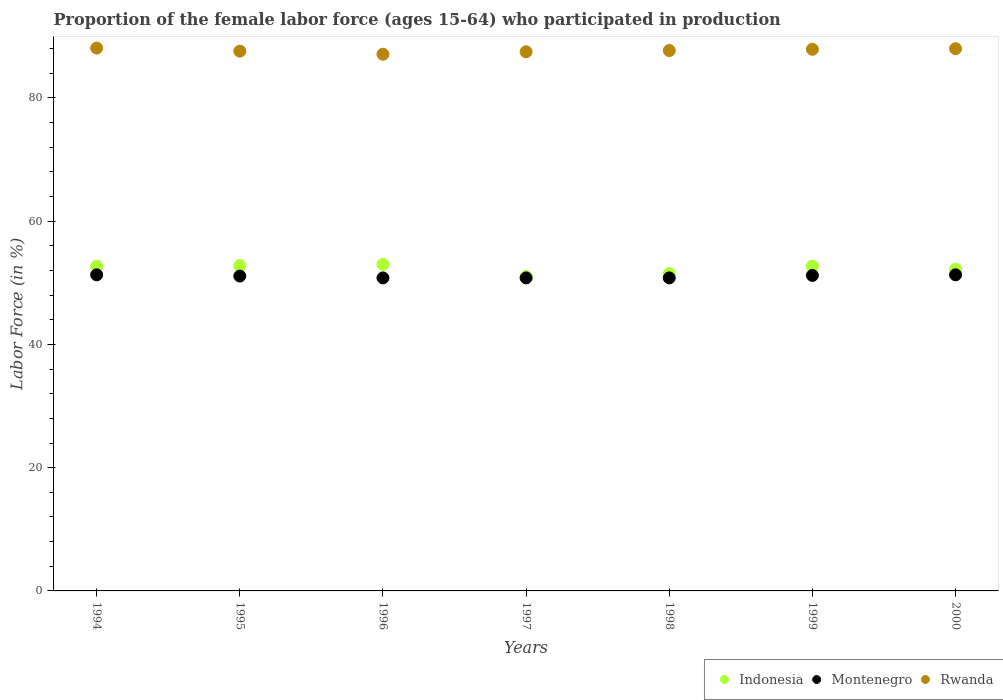What is the proportion of the female labor force who participated in production in Indonesia in 1996?
Give a very brief answer. 53. Across all years, what is the maximum proportion of the female labor force who participated in production in Montenegro?
Ensure brevity in your answer.  51.3. Across all years, what is the minimum proportion of the female labor force who participated in production in Montenegro?
Keep it short and to the point. 50.8. In which year was the proportion of the female labor force who participated in production in Rwanda maximum?
Your response must be concise. 1994. What is the total proportion of the female labor force who participated in production in Montenegro in the graph?
Keep it short and to the point. 357.3. What is the difference between the proportion of the female labor force who participated in production in Indonesia in 1996 and that in 1997?
Give a very brief answer. 2. What is the difference between the proportion of the female labor force who participated in production in Rwanda in 1994 and the proportion of the female labor force who participated in production in Indonesia in 1995?
Your answer should be very brief. 35.3. What is the average proportion of the female labor force who participated in production in Indonesia per year?
Offer a very short reply. 52.27. In the year 1997, what is the difference between the proportion of the female labor force who participated in production in Indonesia and proportion of the female labor force who participated in production in Rwanda?
Give a very brief answer. -36.5. In how many years, is the proportion of the female labor force who participated in production in Rwanda greater than 60 %?
Your response must be concise. 7. What is the ratio of the proportion of the female labor force who participated in production in Montenegro in 1999 to that in 2000?
Give a very brief answer. 1. Is the proportion of the female labor force who participated in production in Montenegro in 1999 less than that in 2000?
Give a very brief answer. Yes. What is the difference between the highest and the second highest proportion of the female labor force who participated in production in Indonesia?
Provide a succinct answer. 0.2. Does the proportion of the female labor force who participated in production in Indonesia monotonically increase over the years?
Offer a terse response. No. Is the proportion of the female labor force who participated in production in Montenegro strictly greater than the proportion of the female labor force who participated in production in Indonesia over the years?
Give a very brief answer. No. Is the proportion of the female labor force who participated in production in Montenegro strictly less than the proportion of the female labor force who participated in production in Rwanda over the years?
Make the answer very short. Yes. How many years are there in the graph?
Keep it short and to the point. 7. What is the difference between two consecutive major ticks on the Y-axis?
Your response must be concise. 20. Does the graph contain any zero values?
Make the answer very short. No. Does the graph contain grids?
Give a very brief answer. No. Where does the legend appear in the graph?
Your response must be concise. Bottom right. What is the title of the graph?
Keep it short and to the point. Proportion of the female labor force (ages 15-64) who participated in production. What is the label or title of the Y-axis?
Keep it short and to the point. Labor Force (in %). What is the Labor Force (in %) in Indonesia in 1994?
Offer a very short reply. 52.7. What is the Labor Force (in %) in Montenegro in 1994?
Give a very brief answer. 51.3. What is the Labor Force (in %) of Rwanda in 1994?
Give a very brief answer. 88.1. What is the Labor Force (in %) of Indonesia in 1995?
Keep it short and to the point. 52.8. What is the Labor Force (in %) in Montenegro in 1995?
Your response must be concise. 51.1. What is the Labor Force (in %) of Rwanda in 1995?
Offer a terse response. 87.6. What is the Labor Force (in %) of Montenegro in 1996?
Your response must be concise. 50.8. What is the Labor Force (in %) of Rwanda in 1996?
Give a very brief answer. 87.1. What is the Labor Force (in %) in Montenegro in 1997?
Your answer should be compact. 50.8. What is the Labor Force (in %) in Rwanda in 1997?
Your answer should be compact. 87.5. What is the Labor Force (in %) in Indonesia in 1998?
Ensure brevity in your answer.  51.5. What is the Labor Force (in %) of Montenegro in 1998?
Offer a very short reply. 50.8. What is the Labor Force (in %) in Rwanda in 1998?
Offer a very short reply. 87.7. What is the Labor Force (in %) of Indonesia in 1999?
Your answer should be compact. 52.7. What is the Labor Force (in %) of Montenegro in 1999?
Provide a short and direct response. 51.2. What is the Labor Force (in %) of Rwanda in 1999?
Your answer should be compact. 87.9. What is the Labor Force (in %) of Indonesia in 2000?
Give a very brief answer. 52.2. What is the Labor Force (in %) in Montenegro in 2000?
Give a very brief answer. 51.3. What is the Labor Force (in %) in Rwanda in 2000?
Ensure brevity in your answer.  88. Across all years, what is the maximum Labor Force (in %) of Indonesia?
Offer a very short reply. 53. Across all years, what is the maximum Labor Force (in %) of Montenegro?
Offer a terse response. 51.3. Across all years, what is the maximum Labor Force (in %) of Rwanda?
Offer a very short reply. 88.1. Across all years, what is the minimum Labor Force (in %) of Indonesia?
Ensure brevity in your answer.  51. Across all years, what is the minimum Labor Force (in %) in Montenegro?
Offer a very short reply. 50.8. Across all years, what is the minimum Labor Force (in %) in Rwanda?
Give a very brief answer. 87.1. What is the total Labor Force (in %) of Indonesia in the graph?
Provide a short and direct response. 365.9. What is the total Labor Force (in %) of Montenegro in the graph?
Ensure brevity in your answer.  357.3. What is the total Labor Force (in %) of Rwanda in the graph?
Provide a short and direct response. 613.9. What is the difference between the Labor Force (in %) of Montenegro in 1994 and that in 1995?
Keep it short and to the point. 0.2. What is the difference between the Labor Force (in %) of Indonesia in 1994 and that in 1996?
Ensure brevity in your answer.  -0.3. What is the difference between the Labor Force (in %) of Montenegro in 1994 and that in 1996?
Your response must be concise. 0.5. What is the difference between the Labor Force (in %) of Rwanda in 1994 and that in 1996?
Your response must be concise. 1. What is the difference between the Labor Force (in %) in Montenegro in 1994 and that in 1997?
Offer a very short reply. 0.5. What is the difference between the Labor Force (in %) in Montenegro in 1994 and that in 1999?
Your response must be concise. 0.1. What is the difference between the Labor Force (in %) of Indonesia in 1994 and that in 2000?
Ensure brevity in your answer.  0.5. What is the difference between the Labor Force (in %) in Indonesia in 1995 and that in 1996?
Your response must be concise. -0.2. What is the difference between the Labor Force (in %) of Rwanda in 1995 and that in 1996?
Ensure brevity in your answer.  0.5. What is the difference between the Labor Force (in %) in Indonesia in 1995 and that in 1997?
Make the answer very short. 1.8. What is the difference between the Labor Force (in %) in Montenegro in 1995 and that in 1997?
Ensure brevity in your answer.  0.3. What is the difference between the Labor Force (in %) in Rwanda in 1995 and that in 1997?
Give a very brief answer. 0.1. What is the difference between the Labor Force (in %) in Rwanda in 1995 and that in 1998?
Keep it short and to the point. -0.1. What is the difference between the Labor Force (in %) in Indonesia in 1995 and that in 1999?
Ensure brevity in your answer.  0.1. What is the difference between the Labor Force (in %) of Montenegro in 1995 and that in 1999?
Provide a short and direct response. -0.1. What is the difference between the Labor Force (in %) of Rwanda in 1995 and that in 2000?
Make the answer very short. -0.4. What is the difference between the Labor Force (in %) of Montenegro in 1996 and that in 1997?
Offer a terse response. 0. What is the difference between the Labor Force (in %) of Indonesia in 1996 and that in 1998?
Offer a very short reply. 1.5. What is the difference between the Labor Force (in %) of Montenegro in 1996 and that in 1998?
Make the answer very short. 0. What is the difference between the Labor Force (in %) in Rwanda in 1996 and that in 1998?
Your response must be concise. -0.6. What is the difference between the Labor Force (in %) in Indonesia in 1996 and that in 1999?
Offer a very short reply. 0.3. What is the difference between the Labor Force (in %) in Montenegro in 1996 and that in 1999?
Give a very brief answer. -0.4. What is the difference between the Labor Force (in %) of Indonesia in 1996 and that in 2000?
Keep it short and to the point. 0.8. What is the difference between the Labor Force (in %) in Rwanda in 1996 and that in 2000?
Ensure brevity in your answer.  -0.9. What is the difference between the Labor Force (in %) of Indonesia in 1997 and that in 1998?
Offer a terse response. -0.5. What is the difference between the Labor Force (in %) in Indonesia in 1998 and that in 1999?
Offer a terse response. -1.2. What is the difference between the Labor Force (in %) in Rwanda in 1998 and that in 1999?
Your answer should be very brief. -0.2. What is the difference between the Labor Force (in %) in Indonesia in 1998 and that in 2000?
Keep it short and to the point. -0.7. What is the difference between the Labor Force (in %) in Montenegro in 1999 and that in 2000?
Give a very brief answer. -0.1. What is the difference between the Labor Force (in %) in Indonesia in 1994 and the Labor Force (in %) in Rwanda in 1995?
Your answer should be compact. -34.9. What is the difference between the Labor Force (in %) in Montenegro in 1994 and the Labor Force (in %) in Rwanda in 1995?
Give a very brief answer. -36.3. What is the difference between the Labor Force (in %) in Indonesia in 1994 and the Labor Force (in %) in Rwanda in 1996?
Your response must be concise. -34.4. What is the difference between the Labor Force (in %) of Montenegro in 1994 and the Labor Force (in %) of Rwanda in 1996?
Ensure brevity in your answer.  -35.8. What is the difference between the Labor Force (in %) of Indonesia in 1994 and the Labor Force (in %) of Montenegro in 1997?
Your response must be concise. 1.9. What is the difference between the Labor Force (in %) in Indonesia in 1994 and the Labor Force (in %) in Rwanda in 1997?
Offer a very short reply. -34.8. What is the difference between the Labor Force (in %) in Montenegro in 1994 and the Labor Force (in %) in Rwanda in 1997?
Your answer should be very brief. -36.2. What is the difference between the Labor Force (in %) in Indonesia in 1994 and the Labor Force (in %) in Montenegro in 1998?
Your answer should be very brief. 1.9. What is the difference between the Labor Force (in %) in Indonesia in 1994 and the Labor Force (in %) in Rwanda in 1998?
Provide a short and direct response. -35. What is the difference between the Labor Force (in %) in Montenegro in 1994 and the Labor Force (in %) in Rwanda in 1998?
Your response must be concise. -36.4. What is the difference between the Labor Force (in %) in Indonesia in 1994 and the Labor Force (in %) in Montenegro in 1999?
Your answer should be compact. 1.5. What is the difference between the Labor Force (in %) in Indonesia in 1994 and the Labor Force (in %) in Rwanda in 1999?
Offer a terse response. -35.2. What is the difference between the Labor Force (in %) in Montenegro in 1994 and the Labor Force (in %) in Rwanda in 1999?
Give a very brief answer. -36.6. What is the difference between the Labor Force (in %) in Indonesia in 1994 and the Labor Force (in %) in Rwanda in 2000?
Your answer should be very brief. -35.3. What is the difference between the Labor Force (in %) of Montenegro in 1994 and the Labor Force (in %) of Rwanda in 2000?
Keep it short and to the point. -36.7. What is the difference between the Labor Force (in %) of Indonesia in 1995 and the Labor Force (in %) of Rwanda in 1996?
Offer a terse response. -34.3. What is the difference between the Labor Force (in %) in Montenegro in 1995 and the Labor Force (in %) in Rwanda in 1996?
Your answer should be compact. -36. What is the difference between the Labor Force (in %) in Indonesia in 1995 and the Labor Force (in %) in Montenegro in 1997?
Keep it short and to the point. 2. What is the difference between the Labor Force (in %) in Indonesia in 1995 and the Labor Force (in %) in Rwanda in 1997?
Your response must be concise. -34.7. What is the difference between the Labor Force (in %) in Montenegro in 1995 and the Labor Force (in %) in Rwanda in 1997?
Your answer should be compact. -36.4. What is the difference between the Labor Force (in %) of Indonesia in 1995 and the Labor Force (in %) of Rwanda in 1998?
Offer a very short reply. -34.9. What is the difference between the Labor Force (in %) of Montenegro in 1995 and the Labor Force (in %) of Rwanda in 1998?
Your answer should be very brief. -36.6. What is the difference between the Labor Force (in %) in Indonesia in 1995 and the Labor Force (in %) in Montenegro in 1999?
Your response must be concise. 1.6. What is the difference between the Labor Force (in %) in Indonesia in 1995 and the Labor Force (in %) in Rwanda in 1999?
Your answer should be very brief. -35.1. What is the difference between the Labor Force (in %) of Montenegro in 1995 and the Labor Force (in %) of Rwanda in 1999?
Your answer should be very brief. -36.8. What is the difference between the Labor Force (in %) of Indonesia in 1995 and the Labor Force (in %) of Rwanda in 2000?
Your answer should be very brief. -35.2. What is the difference between the Labor Force (in %) of Montenegro in 1995 and the Labor Force (in %) of Rwanda in 2000?
Your answer should be very brief. -36.9. What is the difference between the Labor Force (in %) in Indonesia in 1996 and the Labor Force (in %) in Rwanda in 1997?
Make the answer very short. -34.5. What is the difference between the Labor Force (in %) in Montenegro in 1996 and the Labor Force (in %) in Rwanda in 1997?
Give a very brief answer. -36.7. What is the difference between the Labor Force (in %) in Indonesia in 1996 and the Labor Force (in %) in Montenegro in 1998?
Provide a succinct answer. 2.2. What is the difference between the Labor Force (in %) of Indonesia in 1996 and the Labor Force (in %) of Rwanda in 1998?
Your response must be concise. -34.7. What is the difference between the Labor Force (in %) of Montenegro in 1996 and the Labor Force (in %) of Rwanda in 1998?
Ensure brevity in your answer.  -36.9. What is the difference between the Labor Force (in %) of Indonesia in 1996 and the Labor Force (in %) of Rwanda in 1999?
Provide a short and direct response. -34.9. What is the difference between the Labor Force (in %) in Montenegro in 1996 and the Labor Force (in %) in Rwanda in 1999?
Offer a very short reply. -37.1. What is the difference between the Labor Force (in %) of Indonesia in 1996 and the Labor Force (in %) of Rwanda in 2000?
Your answer should be compact. -35. What is the difference between the Labor Force (in %) in Montenegro in 1996 and the Labor Force (in %) in Rwanda in 2000?
Provide a succinct answer. -37.2. What is the difference between the Labor Force (in %) in Indonesia in 1997 and the Labor Force (in %) in Montenegro in 1998?
Offer a terse response. 0.2. What is the difference between the Labor Force (in %) of Indonesia in 1997 and the Labor Force (in %) of Rwanda in 1998?
Provide a short and direct response. -36.7. What is the difference between the Labor Force (in %) in Montenegro in 1997 and the Labor Force (in %) in Rwanda in 1998?
Give a very brief answer. -36.9. What is the difference between the Labor Force (in %) in Indonesia in 1997 and the Labor Force (in %) in Rwanda in 1999?
Make the answer very short. -36.9. What is the difference between the Labor Force (in %) in Montenegro in 1997 and the Labor Force (in %) in Rwanda in 1999?
Ensure brevity in your answer.  -37.1. What is the difference between the Labor Force (in %) of Indonesia in 1997 and the Labor Force (in %) of Rwanda in 2000?
Make the answer very short. -37. What is the difference between the Labor Force (in %) of Montenegro in 1997 and the Labor Force (in %) of Rwanda in 2000?
Give a very brief answer. -37.2. What is the difference between the Labor Force (in %) of Indonesia in 1998 and the Labor Force (in %) of Montenegro in 1999?
Ensure brevity in your answer.  0.3. What is the difference between the Labor Force (in %) in Indonesia in 1998 and the Labor Force (in %) in Rwanda in 1999?
Your answer should be very brief. -36.4. What is the difference between the Labor Force (in %) in Montenegro in 1998 and the Labor Force (in %) in Rwanda in 1999?
Your response must be concise. -37.1. What is the difference between the Labor Force (in %) of Indonesia in 1998 and the Labor Force (in %) of Rwanda in 2000?
Make the answer very short. -36.5. What is the difference between the Labor Force (in %) of Montenegro in 1998 and the Labor Force (in %) of Rwanda in 2000?
Your response must be concise. -37.2. What is the difference between the Labor Force (in %) of Indonesia in 1999 and the Labor Force (in %) of Montenegro in 2000?
Offer a very short reply. 1.4. What is the difference between the Labor Force (in %) of Indonesia in 1999 and the Labor Force (in %) of Rwanda in 2000?
Keep it short and to the point. -35.3. What is the difference between the Labor Force (in %) of Montenegro in 1999 and the Labor Force (in %) of Rwanda in 2000?
Make the answer very short. -36.8. What is the average Labor Force (in %) in Indonesia per year?
Your response must be concise. 52.27. What is the average Labor Force (in %) of Montenegro per year?
Your answer should be very brief. 51.04. What is the average Labor Force (in %) of Rwanda per year?
Make the answer very short. 87.7. In the year 1994, what is the difference between the Labor Force (in %) in Indonesia and Labor Force (in %) in Montenegro?
Your answer should be compact. 1.4. In the year 1994, what is the difference between the Labor Force (in %) of Indonesia and Labor Force (in %) of Rwanda?
Your response must be concise. -35.4. In the year 1994, what is the difference between the Labor Force (in %) of Montenegro and Labor Force (in %) of Rwanda?
Your answer should be compact. -36.8. In the year 1995, what is the difference between the Labor Force (in %) of Indonesia and Labor Force (in %) of Rwanda?
Provide a short and direct response. -34.8. In the year 1995, what is the difference between the Labor Force (in %) in Montenegro and Labor Force (in %) in Rwanda?
Give a very brief answer. -36.5. In the year 1996, what is the difference between the Labor Force (in %) of Indonesia and Labor Force (in %) of Rwanda?
Give a very brief answer. -34.1. In the year 1996, what is the difference between the Labor Force (in %) of Montenegro and Labor Force (in %) of Rwanda?
Keep it short and to the point. -36.3. In the year 1997, what is the difference between the Labor Force (in %) of Indonesia and Labor Force (in %) of Montenegro?
Offer a terse response. 0.2. In the year 1997, what is the difference between the Labor Force (in %) in Indonesia and Labor Force (in %) in Rwanda?
Provide a succinct answer. -36.5. In the year 1997, what is the difference between the Labor Force (in %) of Montenegro and Labor Force (in %) of Rwanda?
Give a very brief answer. -36.7. In the year 1998, what is the difference between the Labor Force (in %) in Indonesia and Labor Force (in %) in Montenegro?
Ensure brevity in your answer.  0.7. In the year 1998, what is the difference between the Labor Force (in %) of Indonesia and Labor Force (in %) of Rwanda?
Give a very brief answer. -36.2. In the year 1998, what is the difference between the Labor Force (in %) of Montenegro and Labor Force (in %) of Rwanda?
Offer a very short reply. -36.9. In the year 1999, what is the difference between the Labor Force (in %) of Indonesia and Labor Force (in %) of Montenegro?
Make the answer very short. 1.5. In the year 1999, what is the difference between the Labor Force (in %) of Indonesia and Labor Force (in %) of Rwanda?
Give a very brief answer. -35.2. In the year 1999, what is the difference between the Labor Force (in %) of Montenegro and Labor Force (in %) of Rwanda?
Provide a short and direct response. -36.7. In the year 2000, what is the difference between the Labor Force (in %) of Indonesia and Labor Force (in %) of Montenegro?
Your response must be concise. 0.9. In the year 2000, what is the difference between the Labor Force (in %) of Indonesia and Labor Force (in %) of Rwanda?
Give a very brief answer. -35.8. In the year 2000, what is the difference between the Labor Force (in %) in Montenegro and Labor Force (in %) in Rwanda?
Your answer should be very brief. -36.7. What is the ratio of the Labor Force (in %) in Indonesia in 1994 to that in 1995?
Ensure brevity in your answer.  1. What is the ratio of the Labor Force (in %) in Montenegro in 1994 to that in 1995?
Provide a succinct answer. 1. What is the ratio of the Labor Force (in %) in Rwanda in 1994 to that in 1995?
Offer a terse response. 1.01. What is the ratio of the Labor Force (in %) of Montenegro in 1994 to that in 1996?
Offer a very short reply. 1.01. What is the ratio of the Labor Force (in %) in Rwanda in 1994 to that in 1996?
Provide a short and direct response. 1.01. What is the ratio of the Labor Force (in %) in Montenegro in 1994 to that in 1997?
Offer a very short reply. 1.01. What is the ratio of the Labor Force (in %) in Rwanda in 1994 to that in 1997?
Your answer should be compact. 1.01. What is the ratio of the Labor Force (in %) in Indonesia in 1994 to that in 1998?
Offer a terse response. 1.02. What is the ratio of the Labor Force (in %) of Montenegro in 1994 to that in 1998?
Your answer should be very brief. 1.01. What is the ratio of the Labor Force (in %) in Rwanda in 1994 to that in 1998?
Offer a terse response. 1. What is the ratio of the Labor Force (in %) of Indonesia in 1994 to that in 2000?
Give a very brief answer. 1.01. What is the ratio of the Labor Force (in %) in Montenegro in 1994 to that in 2000?
Your response must be concise. 1. What is the ratio of the Labor Force (in %) in Rwanda in 1994 to that in 2000?
Your response must be concise. 1. What is the ratio of the Labor Force (in %) of Montenegro in 1995 to that in 1996?
Offer a very short reply. 1.01. What is the ratio of the Labor Force (in %) of Indonesia in 1995 to that in 1997?
Offer a very short reply. 1.04. What is the ratio of the Labor Force (in %) in Montenegro in 1995 to that in 1997?
Ensure brevity in your answer.  1.01. What is the ratio of the Labor Force (in %) of Indonesia in 1995 to that in 1998?
Give a very brief answer. 1.03. What is the ratio of the Labor Force (in %) in Montenegro in 1995 to that in 1998?
Offer a very short reply. 1.01. What is the ratio of the Labor Force (in %) in Rwanda in 1995 to that in 1998?
Your answer should be compact. 1. What is the ratio of the Labor Force (in %) in Indonesia in 1995 to that in 1999?
Your response must be concise. 1. What is the ratio of the Labor Force (in %) in Montenegro in 1995 to that in 1999?
Keep it short and to the point. 1. What is the ratio of the Labor Force (in %) of Indonesia in 1995 to that in 2000?
Ensure brevity in your answer.  1.01. What is the ratio of the Labor Force (in %) in Montenegro in 1995 to that in 2000?
Give a very brief answer. 1. What is the ratio of the Labor Force (in %) in Rwanda in 1995 to that in 2000?
Provide a short and direct response. 1. What is the ratio of the Labor Force (in %) in Indonesia in 1996 to that in 1997?
Keep it short and to the point. 1.04. What is the ratio of the Labor Force (in %) of Rwanda in 1996 to that in 1997?
Your answer should be compact. 1. What is the ratio of the Labor Force (in %) in Indonesia in 1996 to that in 1998?
Provide a succinct answer. 1.03. What is the ratio of the Labor Force (in %) in Indonesia in 1996 to that in 1999?
Offer a terse response. 1.01. What is the ratio of the Labor Force (in %) in Montenegro in 1996 to that in 1999?
Your response must be concise. 0.99. What is the ratio of the Labor Force (in %) of Rwanda in 1996 to that in 1999?
Your answer should be compact. 0.99. What is the ratio of the Labor Force (in %) of Indonesia in 1996 to that in 2000?
Provide a short and direct response. 1.02. What is the ratio of the Labor Force (in %) of Montenegro in 1996 to that in 2000?
Give a very brief answer. 0.99. What is the ratio of the Labor Force (in %) in Indonesia in 1997 to that in 1998?
Give a very brief answer. 0.99. What is the ratio of the Labor Force (in %) in Rwanda in 1997 to that in 1998?
Your answer should be compact. 1. What is the ratio of the Labor Force (in %) of Rwanda in 1997 to that in 1999?
Provide a succinct answer. 1. What is the ratio of the Labor Force (in %) of Indonesia in 1997 to that in 2000?
Keep it short and to the point. 0.98. What is the ratio of the Labor Force (in %) of Montenegro in 1997 to that in 2000?
Give a very brief answer. 0.99. What is the ratio of the Labor Force (in %) in Rwanda in 1997 to that in 2000?
Your answer should be very brief. 0.99. What is the ratio of the Labor Force (in %) in Indonesia in 1998 to that in 1999?
Provide a succinct answer. 0.98. What is the ratio of the Labor Force (in %) in Rwanda in 1998 to that in 1999?
Provide a succinct answer. 1. What is the ratio of the Labor Force (in %) in Indonesia in 1998 to that in 2000?
Give a very brief answer. 0.99. What is the ratio of the Labor Force (in %) in Montenegro in 1998 to that in 2000?
Your answer should be compact. 0.99. What is the ratio of the Labor Force (in %) of Indonesia in 1999 to that in 2000?
Give a very brief answer. 1.01. What is the ratio of the Labor Force (in %) in Montenegro in 1999 to that in 2000?
Your answer should be very brief. 1. What is the ratio of the Labor Force (in %) of Rwanda in 1999 to that in 2000?
Ensure brevity in your answer.  1. What is the difference between the highest and the second highest Labor Force (in %) of Montenegro?
Give a very brief answer. 0. What is the difference between the highest and the second highest Labor Force (in %) in Rwanda?
Your answer should be compact. 0.1. What is the difference between the highest and the lowest Labor Force (in %) in Montenegro?
Provide a succinct answer. 0.5. 